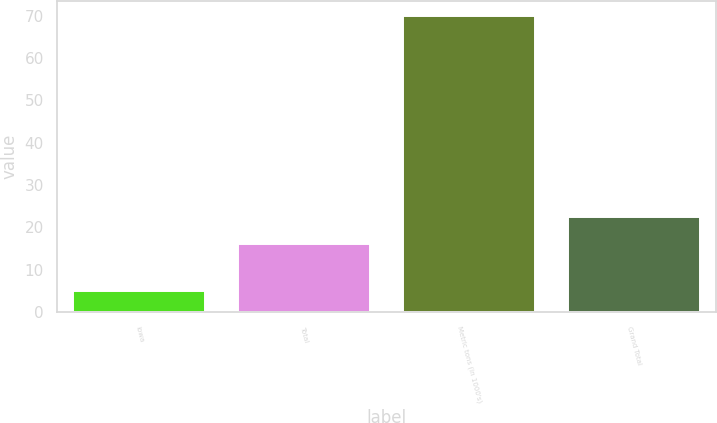Convert chart to OTSL. <chart><loc_0><loc_0><loc_500><loc_500><bar_chart><fcel>Iowa<fcel>Total<fcel>Metric tons (in 1000's)<fcel>Grand Total<nl><fcel>5<fcel>16<fcel>70<fcel>22.5<nl></chart> 